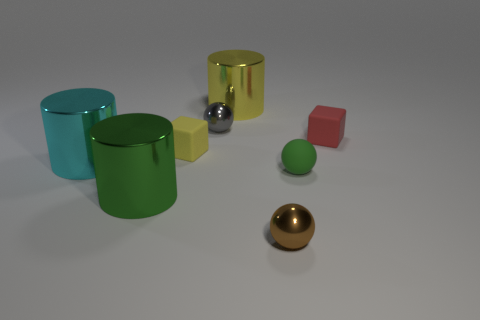There is another ball that is made of the same material as the small gray ball; what is its color?
Give a very brief answer. Brown. There is a cylinder behind the yellow rubber thing; is it the same color as the rubber object to the left of the brown thing?
Offer a terse response. Yes. Is the number of tiny green rubber spheres that are behind the small gray metallic thing greater than the number of big shiny cylinders that are to the right of the tiny rubber ball?
Offer a very short reply. No. The matte object that is the same shape as the small gray metallic thing is what color?
Provide a short and direct response. Green. Do the red rubber thing and the rubber object on the left side of the brown object have the same shape?
Provide a short and direct response. Yes. How many other objects are there of the same material as the red object?
Give a very brief answer. 2. There is a rubber sphere; is it the same color as the small matte block that is left of the large yellow cylinder?
Provide a succinct answer. No. What is the material of the small ball behind the cyan shiny thing?
Provide a short and direct response. Metal. Are there any metallic cylinders that have the same color as the small matte ball?
Offer a very short reply. Yes. The other shiny sphere that is the same size as the gray metallic ball is what color?
Ensure brevity in your answer.  Brown. 